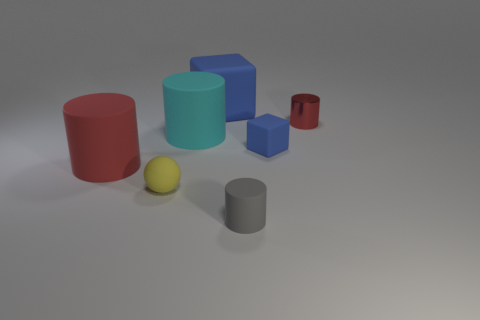Add 3 small yellow rubber spheres. How many objects exist? 10 Subtract all spheres. How many objects are left? 6 Subtract all tiny things. Subtract all large cyan cylinders. How many objects are left? 2 Add 2 big blocks. How many big blocks are left? 3 Add 7 small metallic objects. How many small metallic objects exist? 8 Subtract 0 green spheres. How many objects are left? 7 